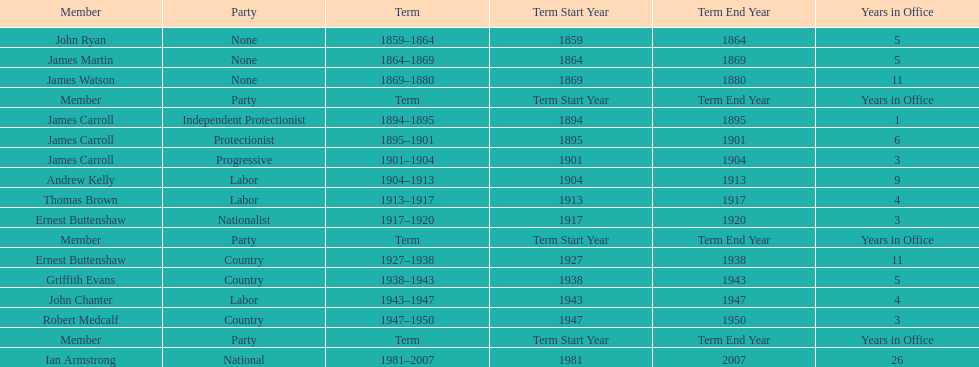Of the members of the third incarnation of the lachlan, who served the longest? Ernest Buttenshaw. Can you parse all the data within this table? {'header': ['Member', 'Party', 'Term', 'Term Start Year', 'Term End Year', 'Years in Office'], 'rows': [['John Ryan', 'None', '1859–1864', '1859', '1864', '5'], ['James Martin', 'None', '1864–1869', '1864', '1869', '5'], ['James Watson', 'None', '1869–1880', '1869', '1880', '11'], ['Member', 'Party', 'Term', 'Term Start Year', 'Term End Year', 'Years in Office'], ['James Carroll', 'Independent Protectionist', '1894–1895', '1894', '1895', '1'], ['James Carroll', 'Protectionist', '1895–1901', '1895', '1901', '6'], ['James Carroll', 'Progressive', '1901–1904', '1901', '1904', '3'], ['Andrew Kelly', 'Labor', '1904–1913', '1904', '1913', '9'], ['Thomas Brown', 'Labor', '1913–1917', '1913', '1917', '4'], ['Ernest Buttenshaw', 'Nationalist', '1917–1920', '1917', '1920', '3'], ['Member', 'Party', 'Term', 'Term Start Year', 'Term End Year', 'Years in Office'], ['Ernest Buttenshaw', 'Country', '1927–1938', '1927', '1938', '11'], ['Griffith Evans', 'Country', '1938–1943', '1938', '1943', '5'], ['John Chanter', 'Labor', '1943–1947', '1943', '1947', '4'], ['Robert Medcalf', 'Country', '1947–1950', '1947', '1950', '3'], ['Member', 'Party', 'Term', 'Term Start Year', 'Term End Year', 'Years in Office'], ['Ian Armstrong', 'National', '1981–2007', '1981', '2007', '26']]} 